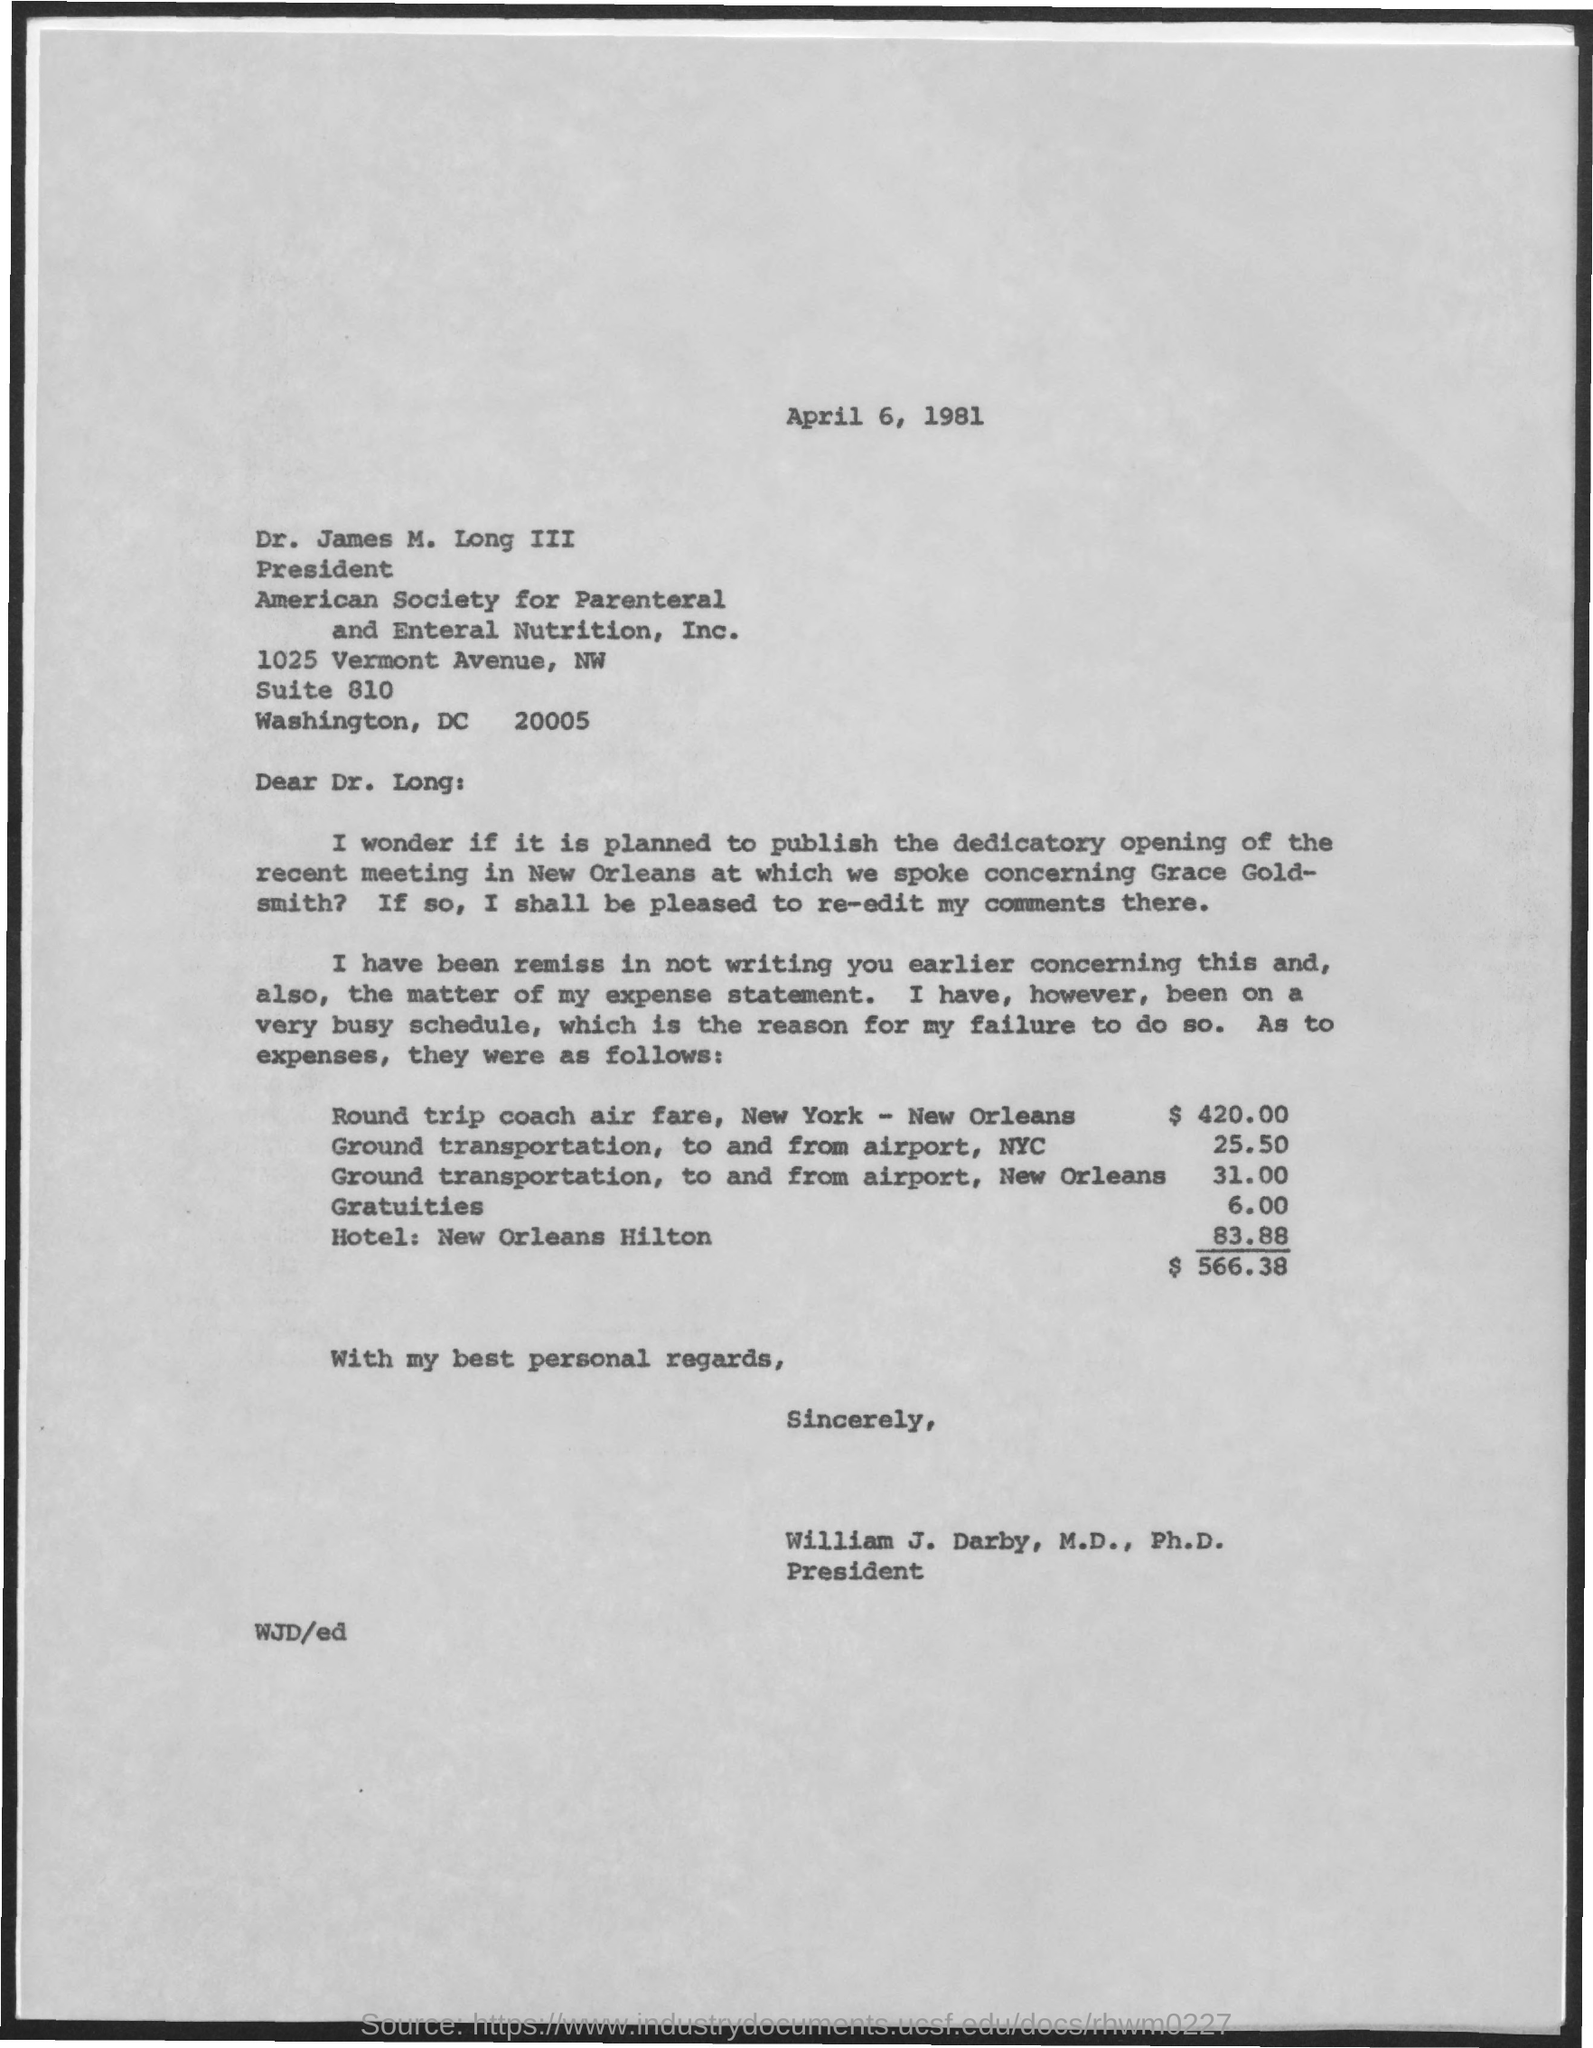What is total expenses?
Keep it short and to the point. $ 566.38. 